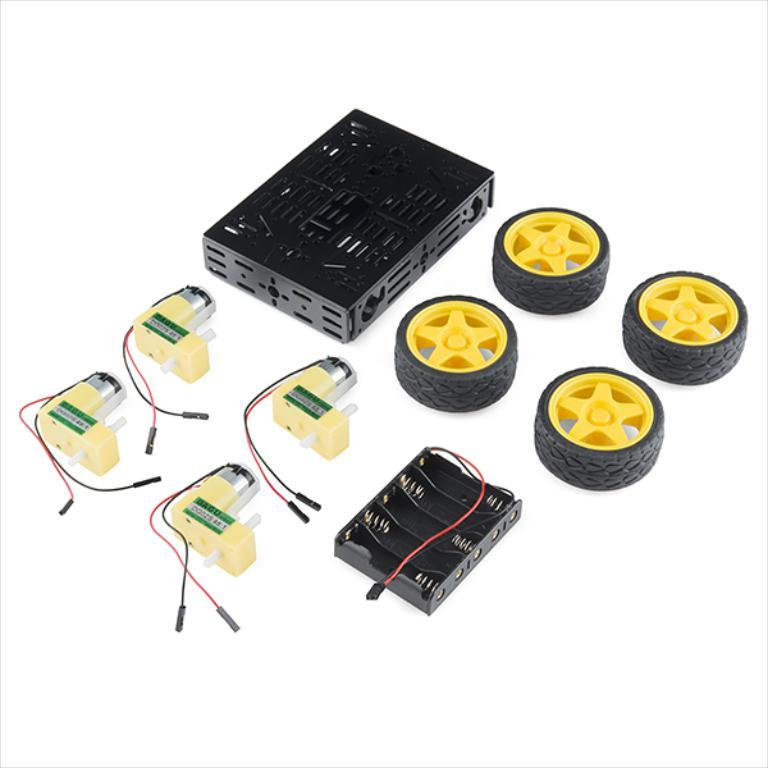How many mini boards are present in the image? There are two mini boards in the image. What other object can be seen in the image? There is a multi chassis in the image. How many wheels are visible in the image? There are four wheels in the image. What type of waste is being disposed of in the image? There is no waste present in the image; it features two mini boards, a multi chassis, and four wheels. What theory is being discussed or demonstrated in the image? There is no theory being discussed or demonstrated in the image; it focuses on the mini boards, multi chassis, and wheels. 